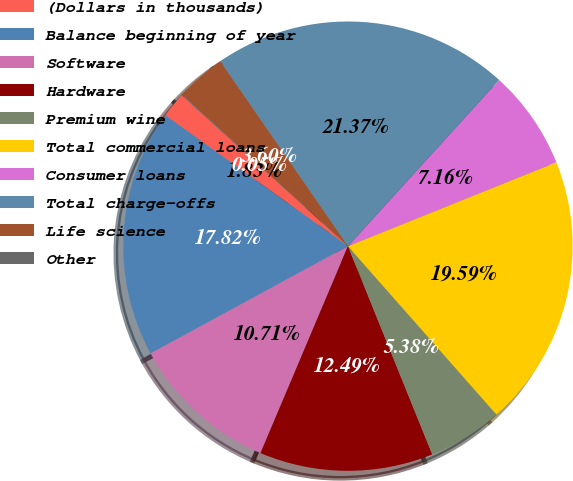<chart> <loc_0><loc_0><loc_500><loc_500><pie_chart><fcel>(Dollars in thousands)<fcel>Balance beginning of year<fcel>Software<fcel>Hardware<fcel>Premium wine<fcel>Total commercial loans<fcel>Consumer loans<fcel>Total charge-offs<fcel>Life science<fcel>Other<nl><fcel>1.83%<fcel>17.82%<fcel>10.71%<fcel>12.49%<fcel>5.38%<fcel>19.59%<fcel>7.16%<fcel>21.37%<fcel>3.6%<fcel>0.05%<nl></chart> 